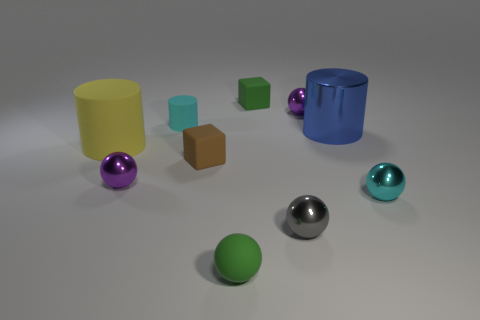Is there another matte cylinder that has the same color as the large matte cylinder?
Keep it short and to the point. No. What color is the matte cylinder that is the same size as the blue metal thing?
Ensure brevity in your answer.  Yellow. How many large things are cyan rubber spheres or green matte spheres?
Your response must be concise. 0. Are there an equal number of balls that are behind the tiny rubber sphere and large yellow rubber cylinders that are behind the blue metallic object?
Make the answer very short. No. What number of purple metal balls have the same size as the cyan rubber cylinder?
Provide a short and direct response. 2. What number of blue objects are either big metal things or tiny rubber spheres?
Offer a terse response. 1. Are there the same number of tiny rubber cylinders to the right of the big blue metal thing and cyan metallic cylinders?
Offer a terse response. Yes. There is a cylinder that is to the right of the gray object; what size is it?
Provide a short and direct response. Large. What number of green things are the same shape as the cyan matte object?
Give a very brief answer. 0. What material is the object that is both behind the brown cube and on the left side of the small cyan rubber object?
Your answer should be very brief. Rubber. 